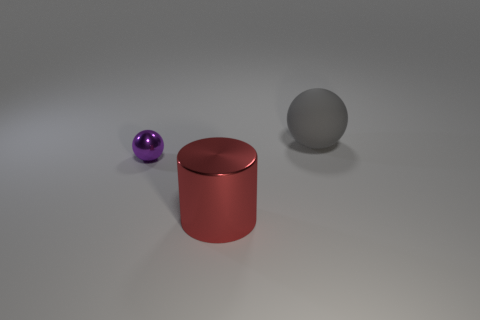What material is the red cylinder?
Give a very brief answer. Metal. The other object that is the same material as the tiny purple thing is what shape?
Offer a very short reply. Cylinder. There is a sphere that is on the left side of the big object that is behind the big metal cylinder; what size is it?
Keep it short and to the point. Small. What color is the ball that is behind the metal sphere?
Offer a very short reply. Gray. Are there any small purple things that have the same shape as the gray object?
Keep it short and to the point. Yes. Are there fewer red metal cylinders that are behind the shiny cylinder than cylinders on the left side of the big gray sphere?
Provide a succinct answer. Yes. What color is the matte thing?
Give a very brief answer. Gray. Is there a tiny purple object to the right of the ball in front of the large ball?
Your answer should be compact. No. How many red cylinders are the same size as the gray rubber ball?
Give a very brief answer. 1. What number of spheres are to the right of the large thing behind the big thing that is left of the big matte ball?
Your response must be concise. 0. 